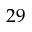Convert formula to latex. <formula><loc_0><loc_0><loc_500><loc_500>2 9</formula> 